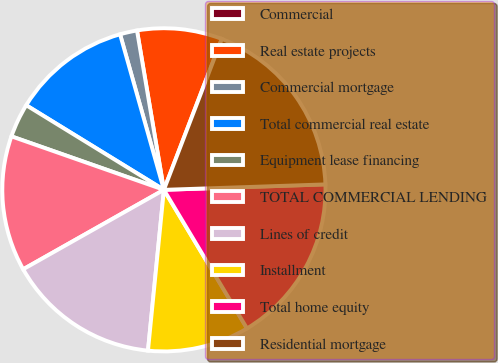Convert chart. <chart><loc_0><loc_0><loc_500><loc_500><pie_chart><fcel>Commercial<fcel>Real estate projects<fcel>Commercial mortgage<fcel>Total commercial real estate<fcel>Equipment lease financing<fcel>TOTAL COMMERCIAL LENDING<fcel>Lines of credit<fcel>Installment<fcel>Total home equity<fcel>Residential mortgage<nl><fcel>0.02%<fcel>8.48%<fcel>1.71%<fcel>11.86%<fcel>3.4%<fcel>13.55%<fcel>15.25%<fcel>10.17%<fcel>16.94%<fcel>18.63%<nl></chart> 